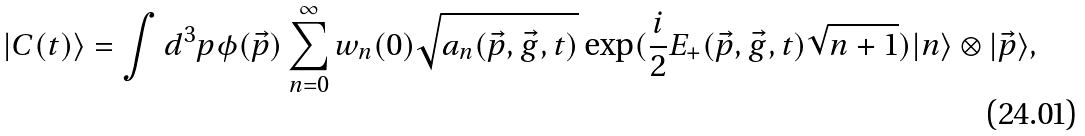Convert formula to latex. <formula><loc_0><loc_0><loc_500><loc_500>| C ( t ) \rangle = \int d ^ { 3 } p \phi ( \vec { p } ) \sum _ { n = 0 } ^ { \infty } w _ { n } ( 0 ) \sqrt { a _ { n } ( \vec { p } , \vec { g } , t ) } \exp ( \frac { i } { 2 } E _ { + } ( \vec { p } , \vec { g } , t ) \sqrt { n + 1 } ) | n \rangle \otimes | \vec { p } \rangle ,</formula> 